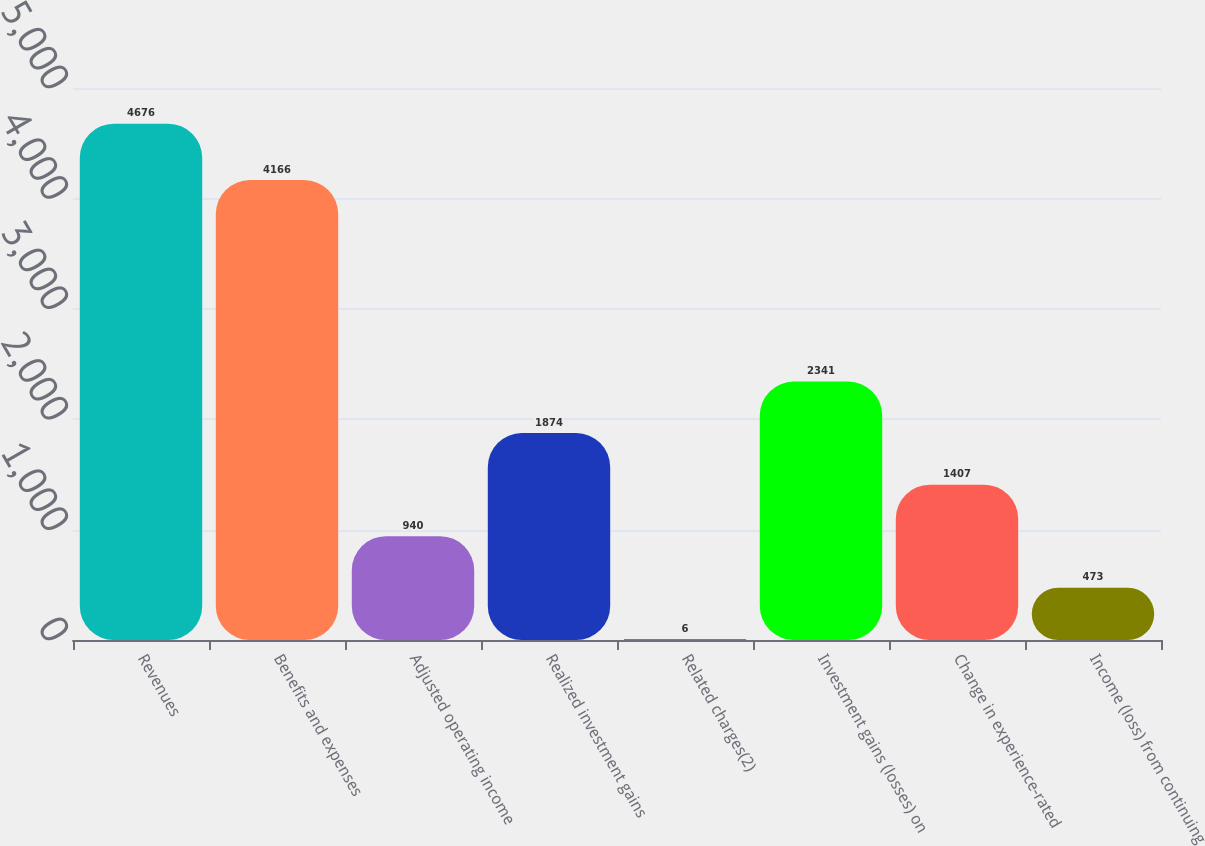<chart> <loc_0><loc_0><loc_500><loc_500><bar_chart><fcel>Revenues<fcel>Benefits and expenses<fcel>Adjusted operating income<fcel>Realized investment gains<fcel>Related charges(2)<fcel>Investment gains (losses) on<fcel>Change in experience-rated<fcel>Income (loss) from continuing<nl><fcel>4676<fcel>4166<fcel>940<fcel>1874<fcel>6<fcel>2341<fcel>1407<fcel>473<nl></chart> 